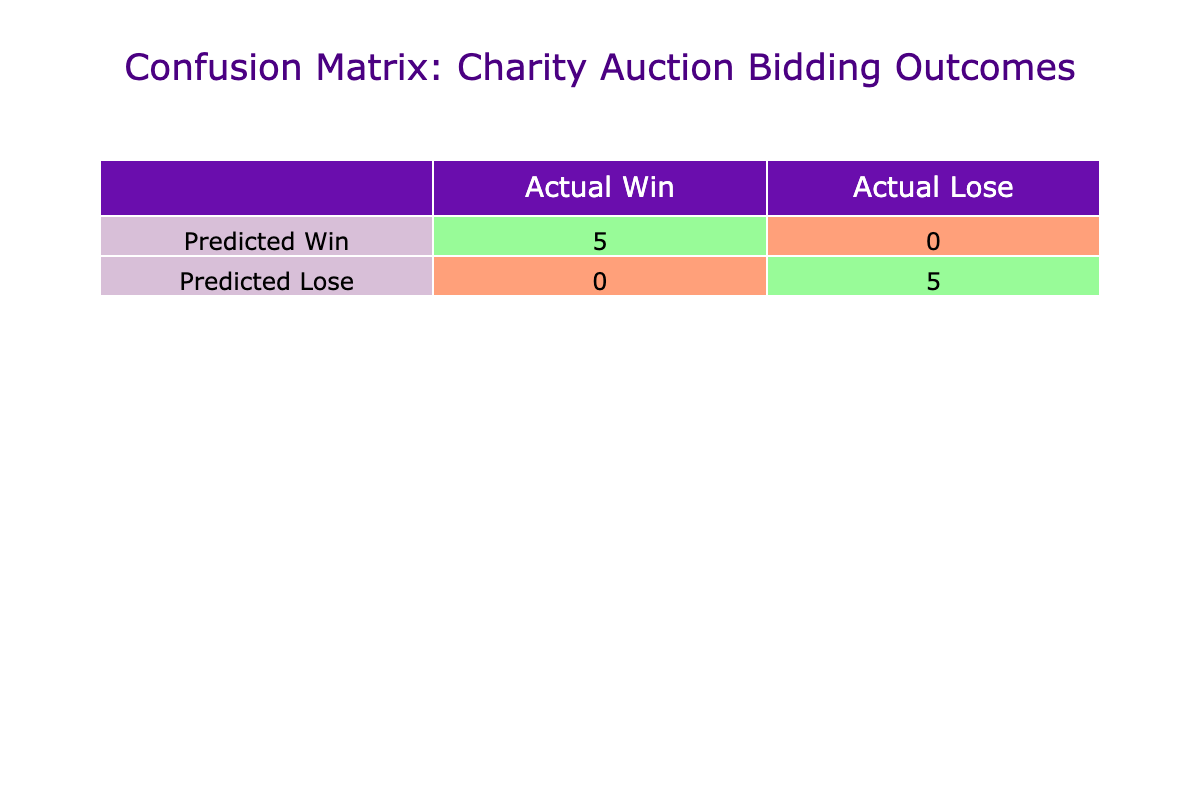What is the total count of winning bids? To find the total count of winning bids, we can refer to the "Win" count in the confusion matrix of the table. The matrix shows that there are 5 winning outcomes.
Answer: 5 How many bidders lost their bids? We can determine the number of bidders that lost their bids by looking at the "Lose" count in the confusion matrix. According to the table, there are 4 losing outcomes.
Answer: 4 Is there a difference between the number of wins and losses? Yes, we can compare the count of winning bids (5) with the count of losing bids (4). The difference is 5 - 4 = 1, indicating that there was one more win than a loss.
Answer: Yes What percentage of bidders won their bids? To find the percentage of bidders who won their bids, we divide the number of wins (5) by the total number of bidders (9), which is then multiplied by 100: (5/9) * 100 = 55.56%.
Answer: 55.56% How many total bids were placed in the auction? The total number of bids can be determined by counting all the unique bidders in the dataset. There are 9 bidders listed in the auction.
Answer: 9 Which item had the highest winning bid and what was that amount? The item with the highest winning bid is "Designer Handbag," won by Jack Wilson for 600. This bid surpasses all other winning bids listed in the outcomes of the table.
Answer: Designer Handbag, 600 What is the total value of all the items that were won? To find the total value of the items won, we add the values of the items that correspond to winning bids: 450 (Luxury Weekend Getaway) + 280 (Signed Sports Memorabilia) + 300 (Private Piano Lesson) + 200 (Exclusive Wine Tasting) + 550 (Designer Handbag) = 1780.
Answer: 1780 Did any bidders win despite bidding less than the item value? Yes, the entries show that all winning bids were below the respective item values for the items won, particularly for the Luxury Weekend Getaway and Signed Sports Memorabilia winning bids.
Answer: Yes How many more 'Wins' were there compared to 'Loses' among bidders? From the confusion matrix, there are 5 wins and 4 losses, so to find the difference, we perform the calculation: 5 wins - 4 losses = 1.
Answer: 1 